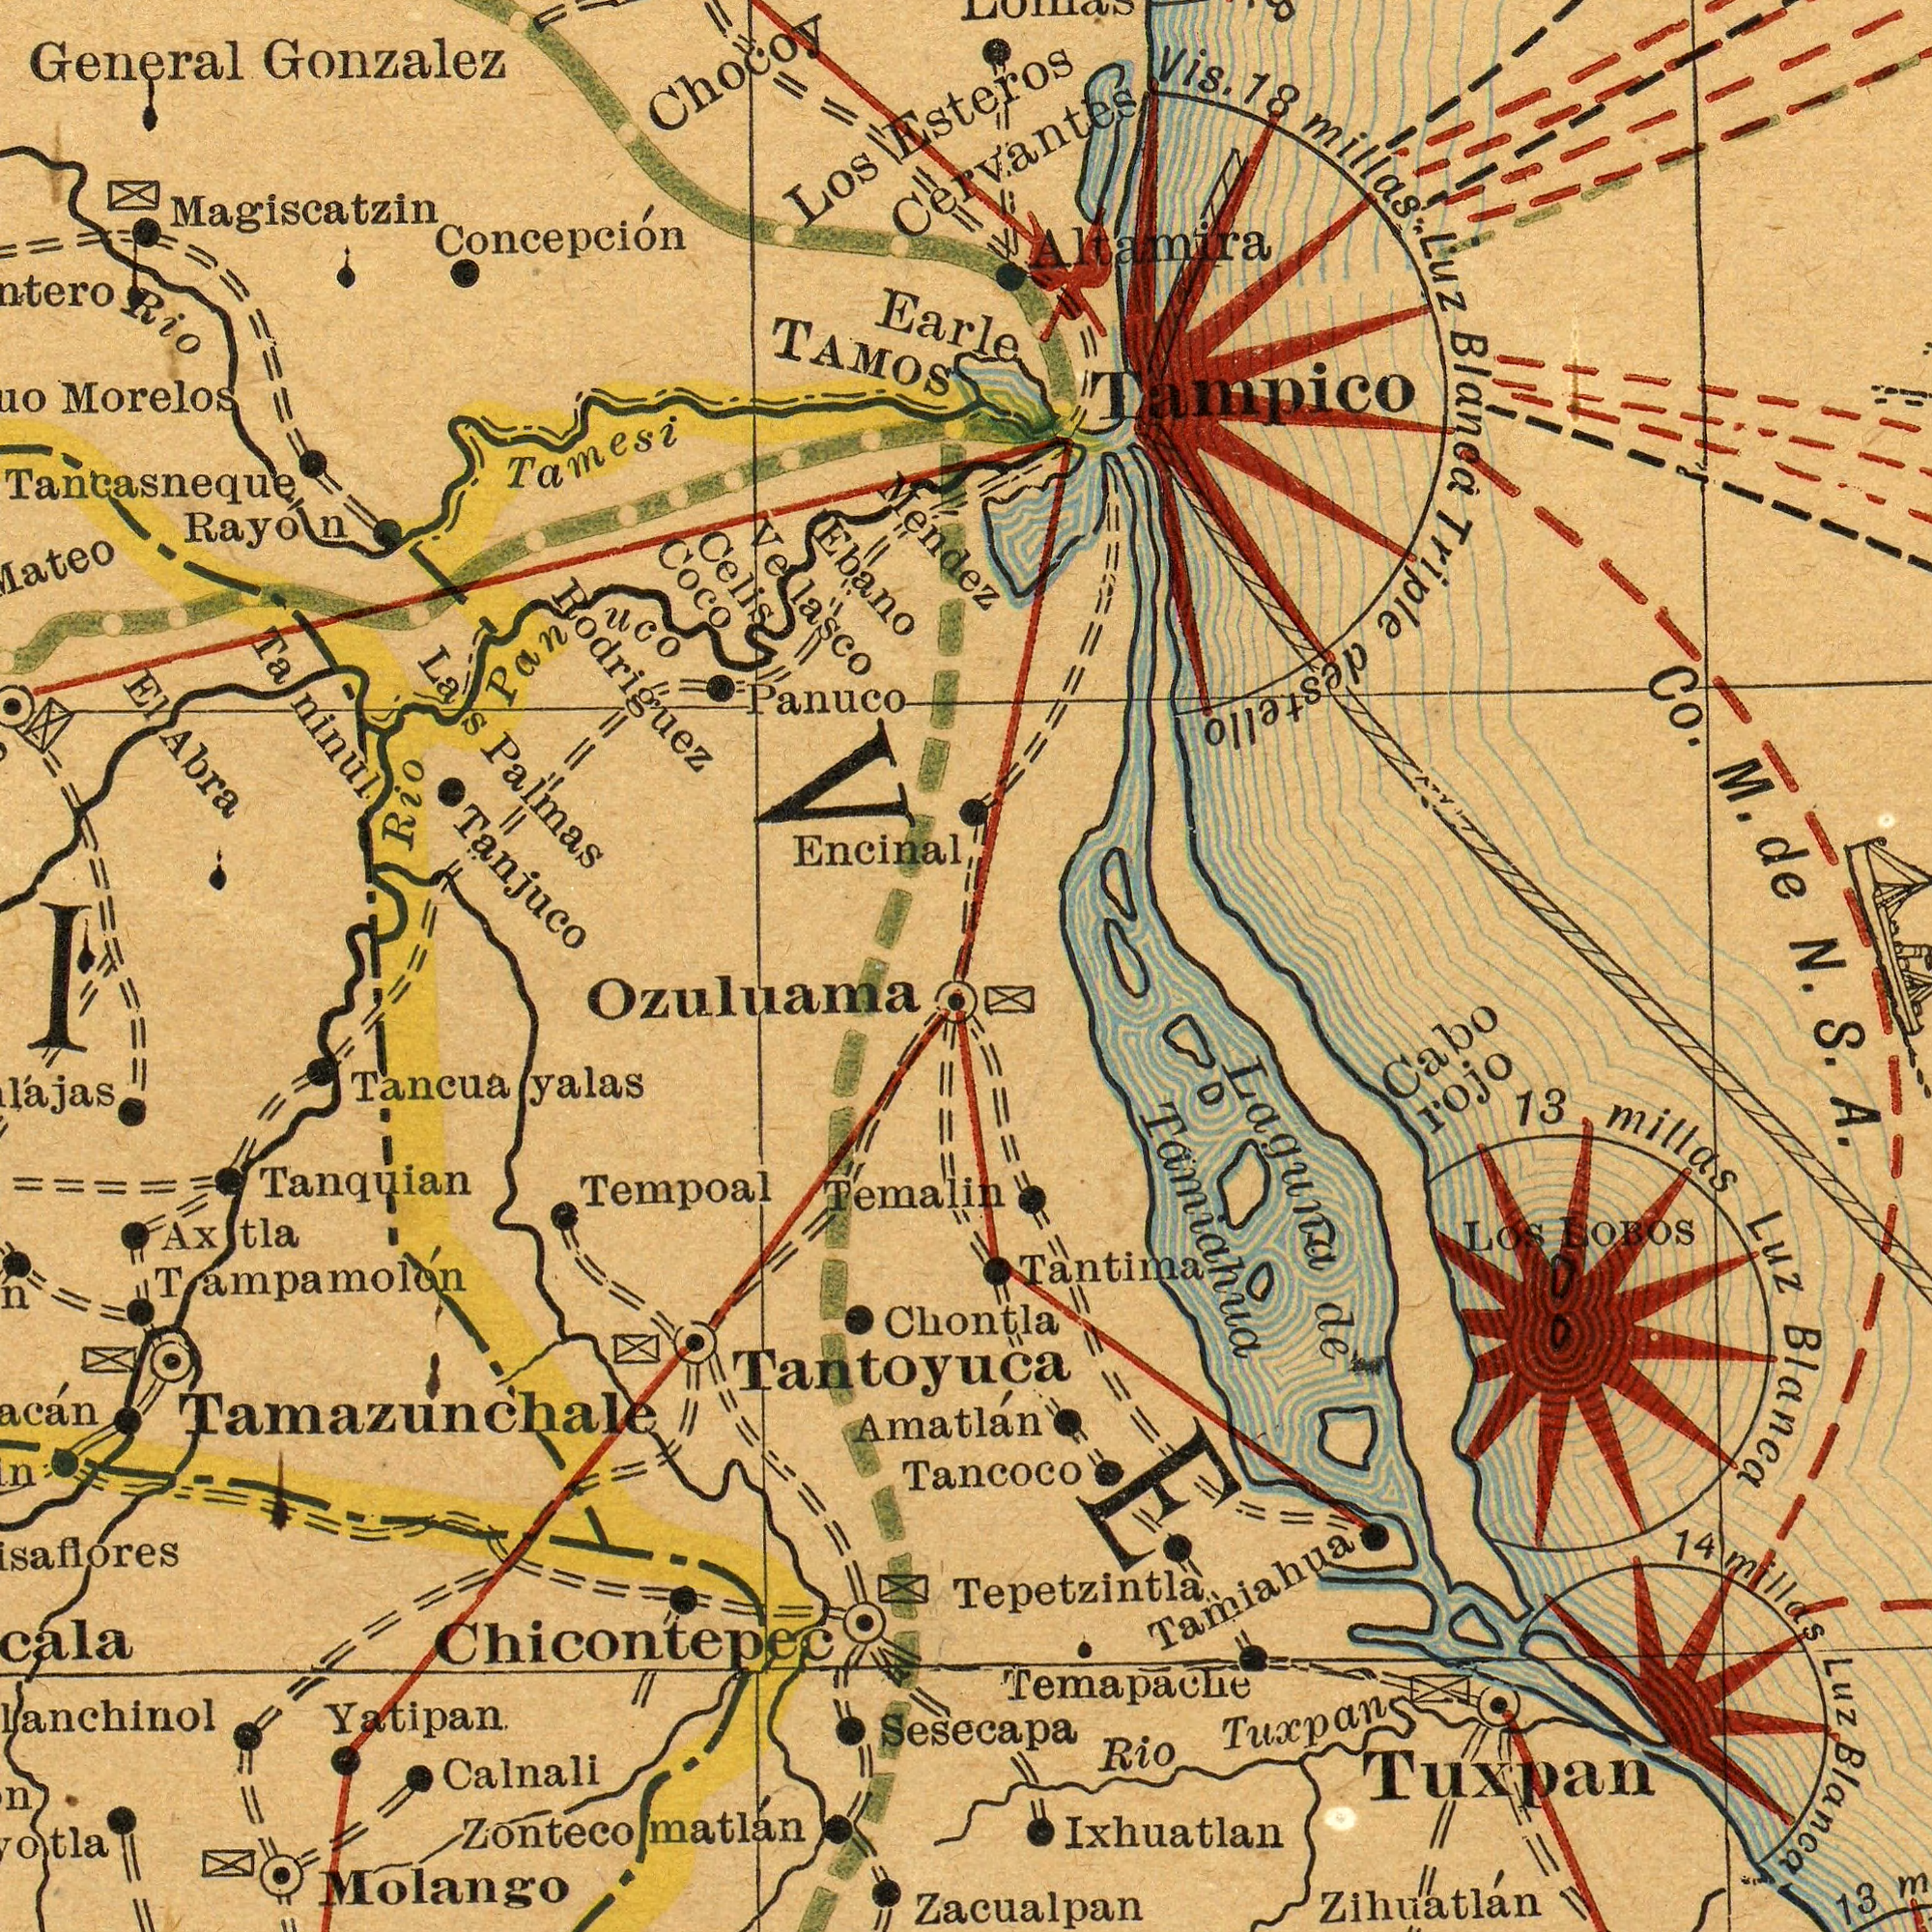What text is visible in the upper-left corner? Velasco Concepción Palmas Magiscatzin Morelos Tamesi General Rodriguez Panuco TAMOS Encinal Tancasneque Rio Tanjuco Celis Los Rayon Rio Gonzalez Abra Ebano Chocoy El Coco uco Mendez Pan Las Taninul What text is visible in the lower-left corner? Molango Calnali Tempoal Yatipan Tancuayalas Ozuluama Tanquian Zontecomatlán Temalin Tantoyuca Axtla Chicontepec Tampamolón Tamazunchale I What text is visible in the lower-right corner? Amatlán Chontla Sesecapa Tancoco Ixhuatlan A. Zacualpan Luz 13 Tamiahua Laguna Temapache Tuxpan millas Tepetzintla Rio LOBOS rojo Cabo Blanca Blanca Zihuatlán Los Tamiahua Luz millas de Tantima Tuxpan S. 13 VE 14 What text is visible in the upper-right corner? Esteros Luz Co. Cervantes Blancá Altamira millas. Earle Vis. M. de N. Tampico 18 Triple destello 